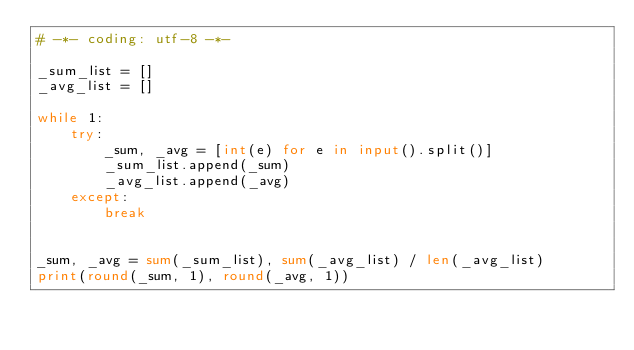<code> <loc_0><loc_0><loc_500><loc_500><_Python_># -*- coding: utf-8 -*-

_sum_list = []
_avg_list = []

while 1:
    try:
        _sum, _avg = [int(e) for e in input().split()]
        _sum_list.append(_sum)
        _avg_list.append(_avg)
    except:
        break


_sum, _avg = sum(_sum_list), sum(_avg_list) / len(_avg_list)
print(round(_sum, 1), round(_avg, 1))</code> 